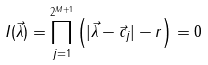<formula> <loc_0><loc_0><loc_500><loc_500>I ( \vec { \lambda } ) = \prod _ { j = 1 } ^ { 2 ^ { M + 1 } } \left ( | \vec { \lambda } - \vec { c } _ { j } | - r \right ) = 0</formula> 